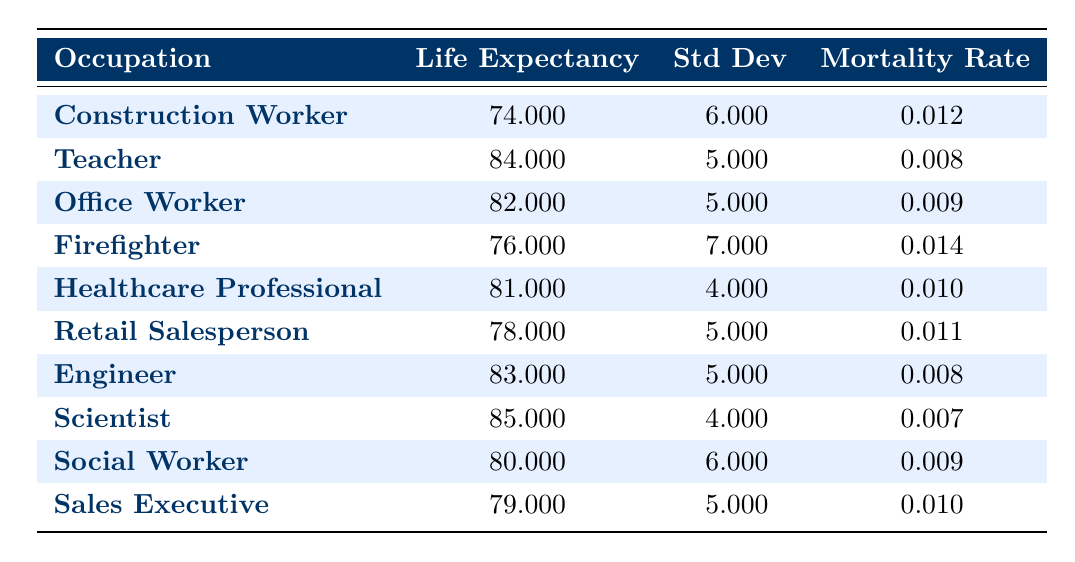What is the average life expectancy for a Teacher? From the table, the entry for Teacher shows an average life expectancy of 84 years.
Answer: 84 Which occupation has the highest mortality rate? Looking at the mortality rates in the table, the Firefighter has the highest rate of 0.014, compared to the other occupations.
Answer: Firefighter What is the difference in life expectancy between Scientists and Construction Workers? Scientists have an average life expectancy of 85 years and Construction Workers have 74 years. The difference is 85 - 74 = 11 years.
Answer: 11 Is the average life expectancy of an Office Worker greater than that of a Retail Salesperson? Office Workers have an average life expectancy of 82 years, while Retail Salespersons have 78 years. Since 82 is greater than 78, the statement is true.
Answer: Yes What is the combined average life expectancy of Healthcare Professionals and Engineers? The average life expectancy of Healthcare Professionals is 81 years and for Engineers, it is 83 years. The combined average is (81 + 83) / 2 = 82 years.
Answer: 82 Which occupation has a standard deviation less than 5? The table shows that both Healthcare Professionals (4) and Scientists (4) have a standard deviation less than 5 years.
Answer: Healthcare Professional, Scientist What is the median life expectancy of the occupations listed in the table? First, we sort the average life expectancy values: 74, 76, 78, 79, 80, 81, 82, 83, 84, 85. With 10 entries, the median is the average of the 5th and 6th values (80 and 81), which is (80 + 81) / 2 = 80.5.
Answer: 80.5 Is it true that all occupations have a life expectancy above 75? Checking the values, Construction Workers have an average life expectancy of 74, which is below 75. Therefore, it is false that all occupations are above this threshold.
Answer: No What is the lowest life expectancy among the listed occupations? Reviewing the averages, Construction Workers have the lowest life expectancy at 74 years compared to others, confirming it as the minimum in this dataset.
Answer: 74 